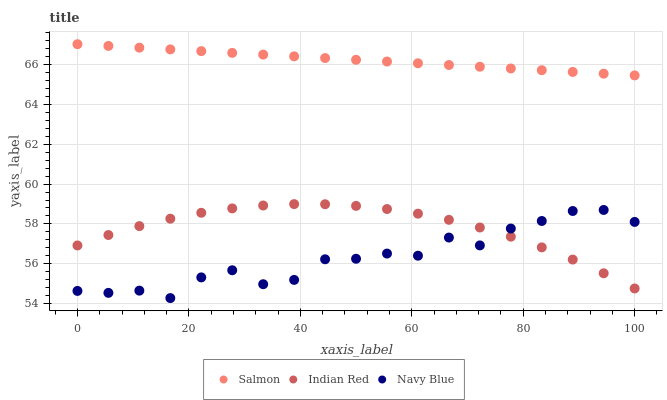Does Navy Blue have the minimum area under the curve?
Answer yes or no. Yes. Does Salmon have the maximum area under the curve?
Answer yes or no. Yes. Does Indian Red have the minimum area under the curve?
Answer yes or no. No. Does Indian Red have the maximum area under the curve?
Answer yes or no. No. Is Salmon the smoothest?
Answer yes or no. Yes. Is Navy Blue the roughest?
Answer yes or no. Yes. Is Indian Red the smoothest?
Answer yes or no. No. Is Indian Red the roughest?
Answer yes or no. No. Does Navy Blue have the lowest value?
Answer yes or no. Yes. Does Indian Red have the lowest value?
Answer yes or no. No. Does Salmon have the highest value?
Answer yes or no. Yes. Does Indian Red have the highest value?
Answer yes or no. No. Is Navy Blue less than Salmon?
Answer yes or no. Yes. Is Salmon greater than Navy Blue?
Answer yes or no. Yes. Does Indian Red intersect Navy Blue?
Answer yes or no. Yes. Is Indian Red less than Navy Blue?
Answer yes or no. No. Is Indian Red greater than Navy Blue?
Answer yes or no. No. Does Navy Blue intersect Salmon?
Answer yes or no. No. 